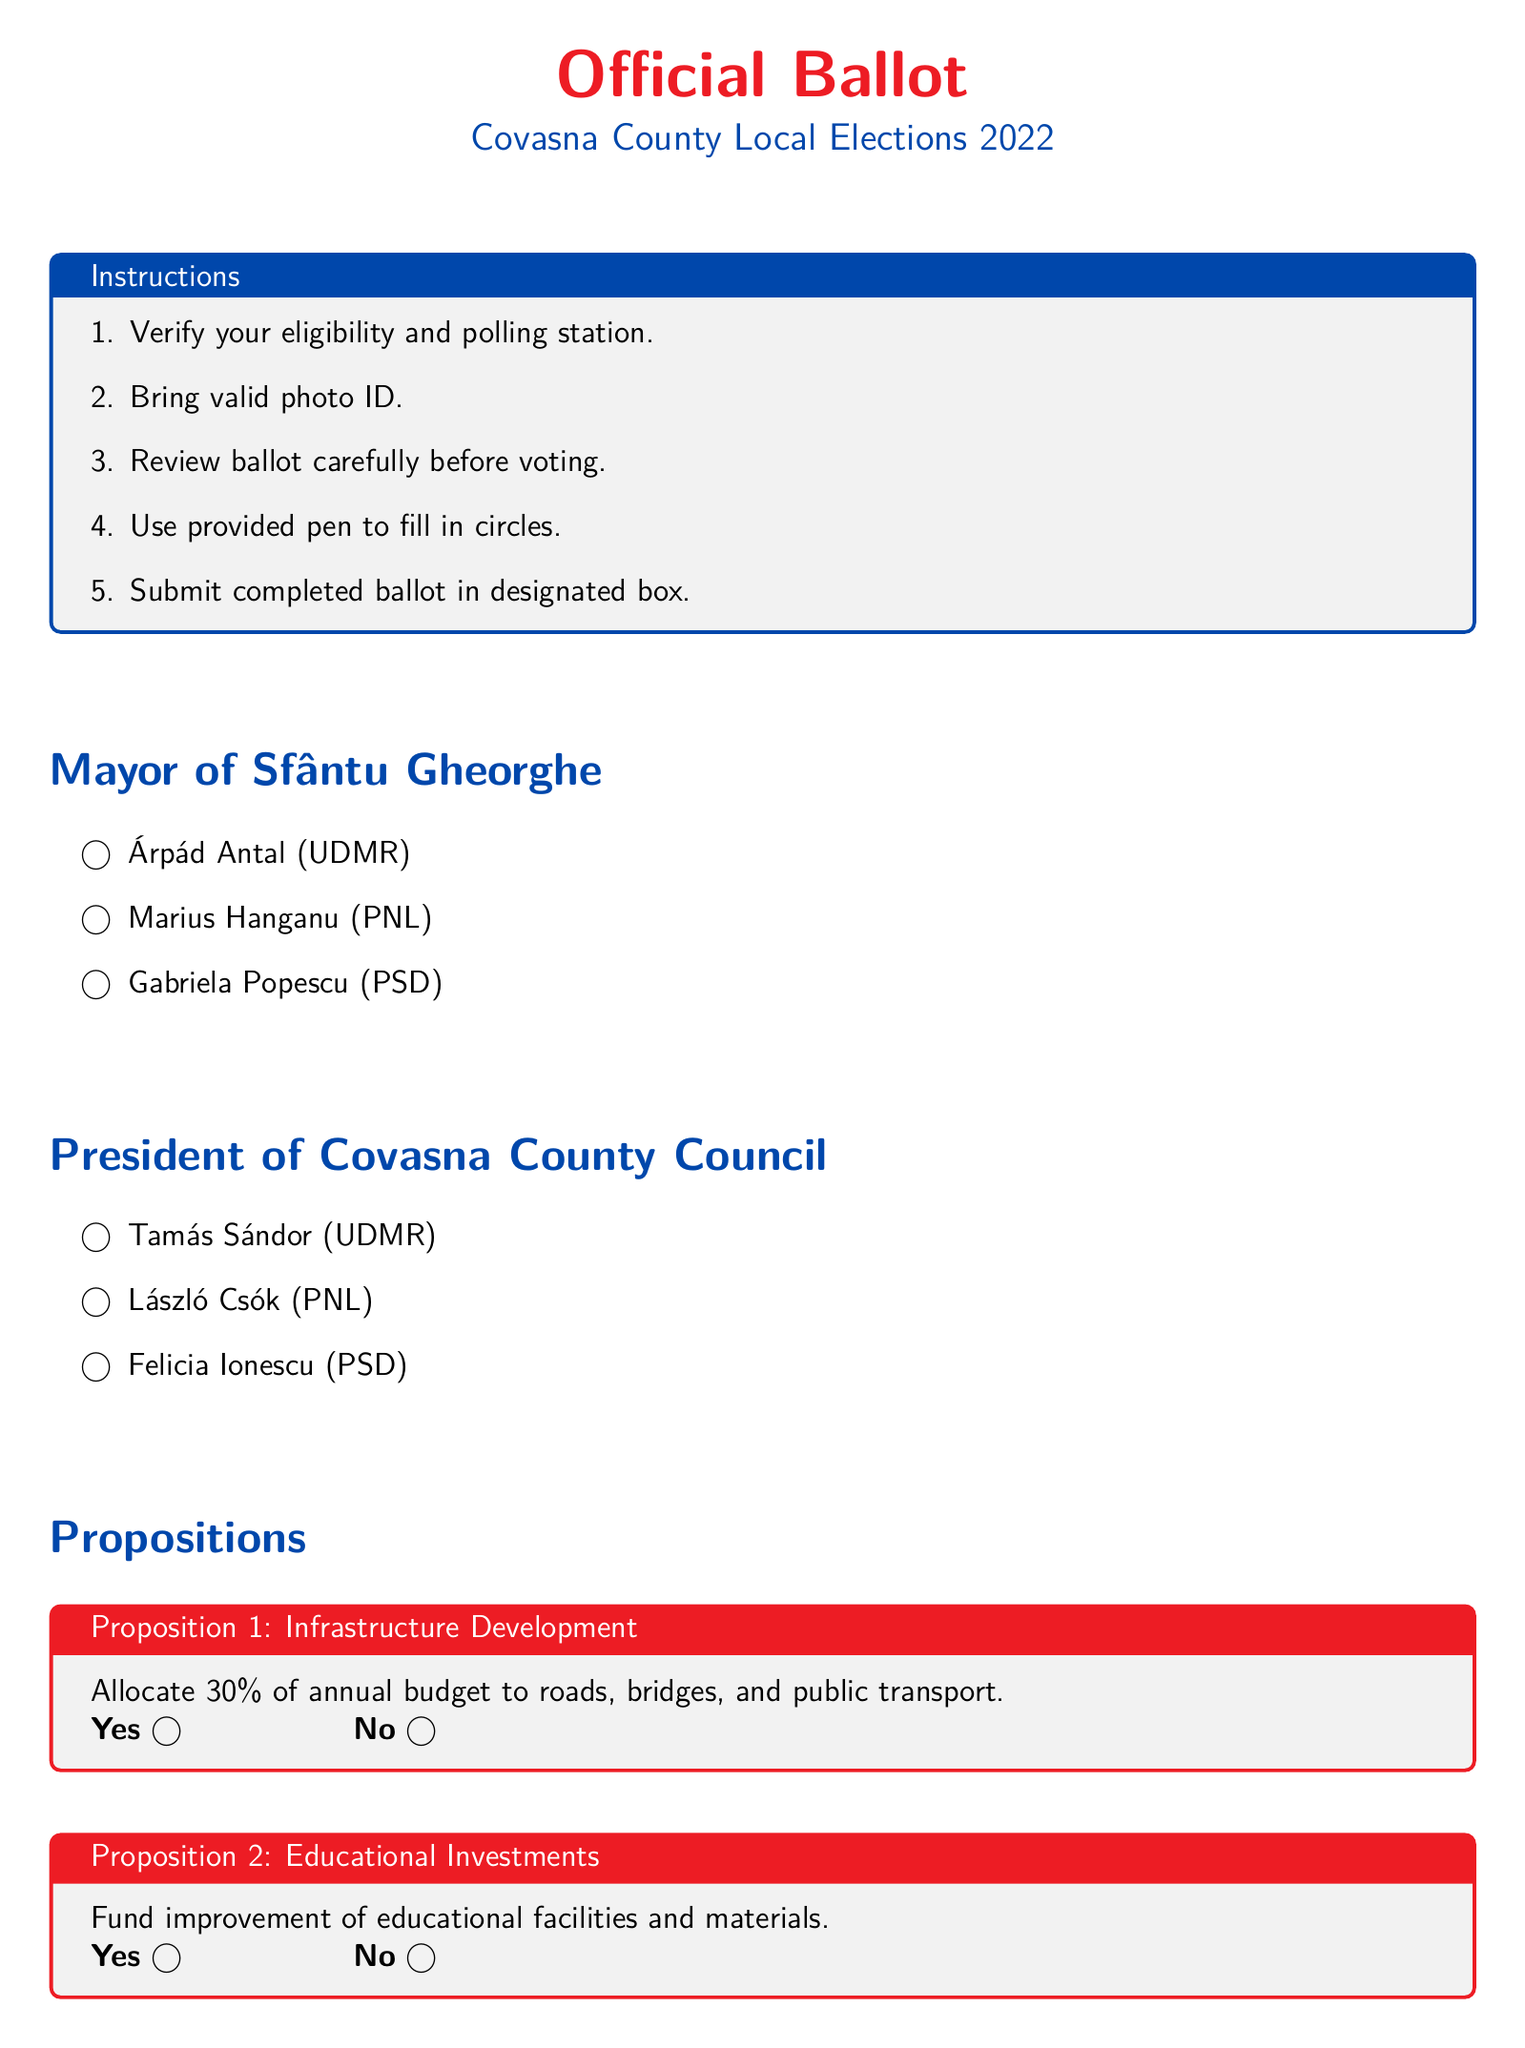What is the title of the ballot? The title appears at the top of the document and states the purpose of the ballot.
Answer: Official Ballot Who is the candidate for Mayor of Sfântu Gheorghe representing PSD? The document lists candidates for mayor and identifies their party affiliations.
Answer: Gabriela Popescu How many propositions are listed in the document? The propositions are clearly outlined in their respective sections, counted to determine the number.
Answer: 3 What percentage of the annual budget is proposed for infrastructure development? The percentage is specified in the Proposition 1 section detailing the allocation amount.
Answer: 30% Who is the candidate for President of Covasna County Council from UDMR? The candidates are identified by their names and political affiliations for this position.
Answer: Tamás Sándor What is required to vote according to the instructions? The instructions list specific items and actions needed to ensure eligibility and proper voting.
Answer: Valid photo ID What is the main focus of Proposition 3? Each proposition describes its purpose, helping to capture the main themes of each.
Answer: Environmental Protection What is the color of the box used for the voting instructions? The instructions section is highlighted with a specific color for emphasis, which can be identified visually.
Answer: Gray What is the closing statement of the document? The document concludes with a statement intended to resonate with voters, emphasizing importance.
Answer: As a proud Romanian and Sepsi OSK fan, your vote matters! 